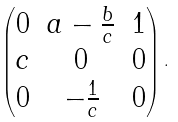<formula> <loc_0><loc_0><loc_500><loc_500>\begin{pmatrix} 0 & a - \frac { b } { c } & 1 \\ c & 0 & 0 \\ 0 & - \frac { 1 } { c } & 0 \end{pmatrix} .</formula> 